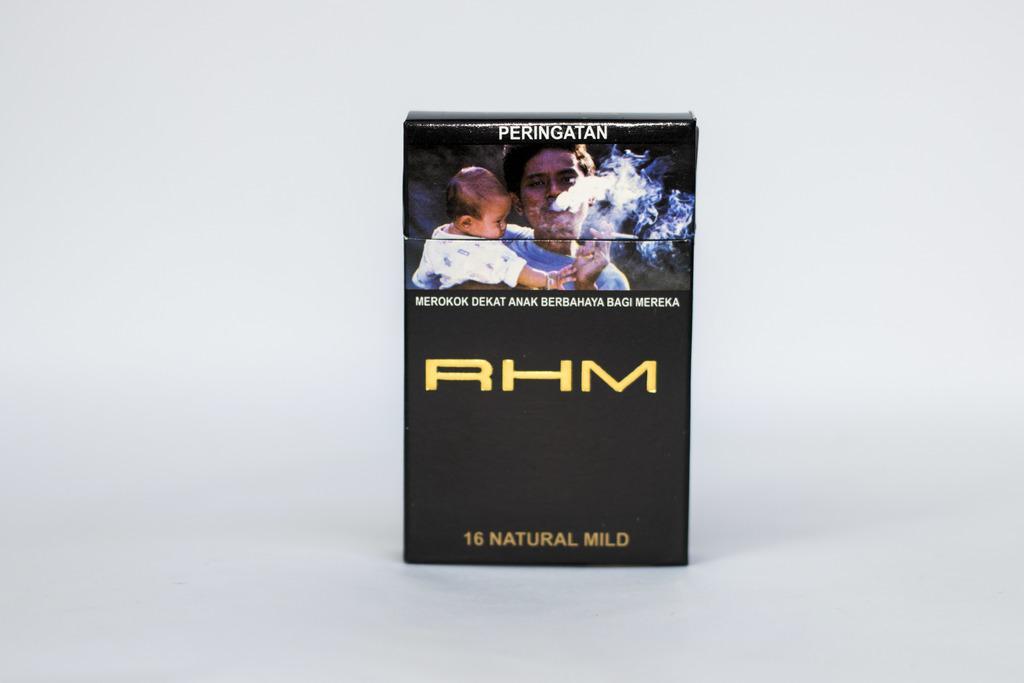Describe this image in one or two sentences. In this image I can see the black color box and I can see two people and something is written on it. I can see the white background. 